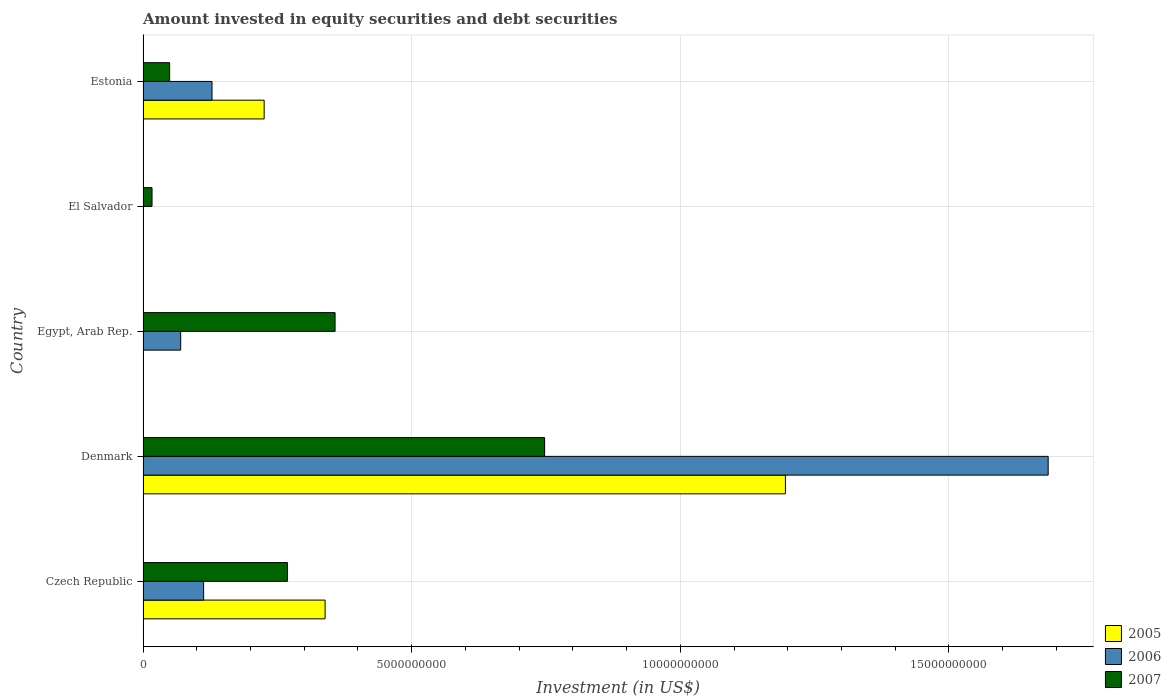How many different coloured bars are there?
Offer a terse response. 3. Are the number of bars on each tick of the Y-axis equal?
Ensure brevity in your answer.  No. What is the label of the 2nd group of bars from the top?
Your answer should be compact. El Salvador. What is the amount invested in equity securities and debt securities in 2007 in El Salvador?
Offer a very short reply. 1.67e+08. Across all countries, what is the maximum amount invested in equity securities and debt securities in 2007?
Provide a succinct answer. 7.47e+09. Across all countries, what is the minimum amount invested in equity securities and debt securities in 2005?
Your answer should be very brief. 0. In which country was the amount invested in equity securities and debt securities in 2007 maximum?
Provide a short and direct response. Denmark. What is the total amount invested in equity securities and debt securities in 2007 in the graph?
Your answer should be very brief. 1.44e+1. What is the difference between the amount invested in equity securities and debt securities in 2007 in Denmark and that in Egypt, Arab Rep.?
Offer a very short reply. 3.90e+09. What is the difference between the amount invested in equity securities and debt securities in 2006 in Czech Republic and the amount invested in equity securities and debt securities in 2005 in Egypt, Arab Rep.?
Make the answer very short. 1.13e+09. What is the average amount invested in equity securities and debt securities in 2006 per country?
Your answer should be compact. 3.99e+09. What is the difference between the amount invested in equity securities and debt securities in 2005 and amount invested in equity securities and debt securities in 2007 in Denmark?
Ensure brevity in your answer.  4.48e+09. In how many countries, is the amount invested in equity securities and debt securities in 2007 greater than 2000000000 US$?
Ensure brevity in your answer.  3. What is the ratio of the amount invested in equity securities and debt securities in 2007 in Czech Republic to that in Denmark?
Your answer should be very brief. 0.36. What is the difference between the highest and the second highest amount invested in equity securities and debt securities in 2006?
Make the answer very short. 1.56e+1. What is the difference between the highest and the lowest amount invested in equity securities and debt securities in 2006?
Provide a short and direct response. 1.68e+1. In how many countries, is the amount invested in equity securities and debt securities in 2006 greater than the average amount invested in equity securities and debt securities in 2006 taken over all countries?
Your answer should be very brief. 1. Is it the case that in every country, the sum of the amount invested in equity securities and debt securities in 2005 and amount invested in equity securities and debt securities in 2007 is greater than the amount invested in equity securities and debt securities in 2006?
Give a very brief answer. Yes. How many countries are there in the graph?
Keep it short and to the point. 5. What is the difference between two consecutive major ticks on the X-axis?
Keep it short and to the point. 5.00e+09. Are the values on the major ticks of X-axis written in scientific E-notation?
Keep it short and to the point. No. Does the graph contain any zero values?
Keep it short and to the point. Yes. Does the graph contain grids?
Keep it short and to the point. Yes. Where does the legend appear in the graph?
Your answer should be compact. Bottom right. What is the title of the graph?
Provide a short and direct response. Amount invested in equity securities and debt securities. Does "2012" appear as one of the legend labels in the graph?
Your answer should be very brief. No. What is the label or title of the X-axis?
Provide a succinct answer. Investment (in US$). What is the Investment (in US$) of 2005 in Czech Republic?
Make the answer very short. 3.39e+09. What is the Investment (in US$) in 2006 in Czech Republic?
Provide a short and direct response. 1.13e+09. What is the Investment (in US$) in 2007 in Czech Republic?
Provide a short and direct response. 2.69e+09. What is the Investment (in US$) of 2005 in Denmark?
Make the answer very short. 1.20e+1. What is the Investment (in US$) in 2006 in Denmark?
Your answer should be compact. 1.68e+1. What is the Investment (in US$) in 2007 in Denmark?
Keep it short and to the point. 7.47e+09. What is the Investment (in US$) of 2005 in Egypt, Arab Rep.?
Offer a terse response. 0. What is the Investment (in US$) in 2006 in Egypt, Arab Rep.?
Keep it short and to the point. 7.00e+08. What is the Investment (in US$) in 2007 in Egypt, Arab Rep.?
Offer a very short reply. 3.57e+09. What is the Investment (in US$) of 2005 in El Salvador?
Your answer should be very brief. 0. What is the Investment (in US$) in 2006 in El Salvador?
Ensure brevity in your answer.  0. What is the Investment (in US$) in 2007 in El Salvador?
Offer a very short reply. 1.67e+08. What is the Investment (in US$) of 2005 in Estonia?
Give a very brief answer. 2.25e+09. What is the Investment (in US$) in 2006 in Estonia?
Give a very brief answer. 1.28e+09. What is the Investment (in US$) in 2007 in Estonia?
Your answer should be compact. 4.95e+08. Across all countries, what is the maximum Investment (in US$) of 2005?
Keep it short and to the point. 1.20e+1. Across all countries, what is the maximum Investment (in US$) in 2006?
Offer a very short reply. 1.68e+1. Across all countries, what is the maximum Investment (in US$) in 2007?
Your response must be concise. 7.47e+09. Across all countries, what is the minimum Investment (in US$) of 2006?
Your answer should be compact. 0. Across all countries, what is the minimum Investment (in US$) of 2007?
Keep it short and to the point. 1.67e+08. What is the total Investment (in US$) in 2005 in the graph?
Your answer should be compact. 1.76e+1. What is the total Investment (in US$) in 2006 in the graph?
Offer a very short reply. 2.00e+1. What is the total Investment (in US$) in 2007 in the graph?
Give a very brief answer. 1.44e+1. What is the difference between the Investment (in US$) in 2005 in Czech Republic and that in Denmark?
Keep it short and to the point. -8.57e+09. What is the difference between the Investment (in US$) of 2006 in Czech Republic and that in Denmark?
Offer a very short reply. -1.57e+1. What is the difference between the Investment (in US$) in 2007 in Czech Republic and that in Denmark?
Ensure brevity in your answer.  -4.79e+09. What is the difference between the Investment (in US$) of 2006 in Czech Republic and that in Egypt, Arab Rep.?
Offer a very short reply. 4.27e+08. What is the difference between the Investment (in US$) in 2007 in Czech Republic and that in Egypt, Arab Rep.?
Make the answer very short. -8.87e+08. What is the difference between the Investment (in US$) in 2007 in Czech Republic and that in El Salvador?
Your response must be concise. 2.52e+09. What is the difference between the Investment (in US$) of 2005 in Czech Republic and that in Estonia?
Provide a succinct answer. 1.13e+09. What is the difference between the Investment (in US$) in 2006 in Czech Republic and that in Estonia?
Your answer should be very brief. -1.56e+08. What is the difference between the Investment (in US$) in 2007 in Czech Republic and that in Estonia?
Your answer should be very brief. 2.19e+09. What is the difference between the Investment (in US$) in 2006 in Denmark and that in Egypt, Arab Rep.?
Keep it short and to the point. 1.61e+1. What is the difference between the Investment (in US$) in 2007 in Denmark and that in Egypt, Arab Rep.?
Provide a short and direct response. 3.90e+09. What is the difference between the Investment (in US$) in 2007 in Denmark and that in El Salvador?
Provide a short and direct response. 7.31e+09. What is the difference between the Investment (in US$) in 2005 in Denmark and that in Estonia?
Ensure brevity in your answer.  9.70e+09. What is the difference between the Investment (in US$) in 2006 in Denmark and that in Estonia?
Provide a succinct answer. 1.56e+1. What is the difference between the Investment (in US$) in 2007 in Denmark and that in Estonia?
Offer a very short reply. 6.98e+09. What is the difference between the Investment (in US$) in 2007 in Egypt, Arab Rep. and that in El Salvador?
Provide a succinct answer. 3.41e+09. What is the difference between the Investment (in US$) in 2006 in Egypt, Arab Rep. and that in Estonia?
Provide a short and direct response. -5.83e+08. What is the difference between the Investment (in US$) in 2007 in Egypt, Arab Rep. and that in Estonia?
Ensure brevity in your answer.  3.08e+09. What is the difference between the Investment (in US$) of 2007 in El Salvador and that in Estonia?
Keep it short and to the point. -3.28e+08. What is the difference between the Investment (in US$) in 2005 in Czech Republic and the Investment (in US$) in 2006 in Denmark?
Provide a short and direct response. -1.35e+1. What is the difference between the Investment (in US$) of 2005 in Czech Republic and the Investment (in US$) of 2007 in Denmark?
Your answer should be compact. -4.09e+09. What is the difference between the Investment (in US$) of 2006 in Czech Republic and the Investment (in US$) of 2007 in Denmark?
Your response must be concise. -6.35e+09. What is the difference between the Investment (in US$) of 2005 in Czech Republic and the Investment (in US$) of 2006 in Egypt, Arab Rep.?
Your response must be concise. 2.69e+09. What is the difference between the Investment (in US$) in 2005 in Czech Republic and the Investment (in US$) in 2007 in Egypt, Arab Rep.?
Provide a succinct answer. -1.86e+08. What is the difference between the Investment (in US$) in 2006 in Czech Republic and the Investment (in US$) in 2007 in Egypt, Arab Rep.?
Your answer should be compact. -2.45e+09. What is the difference between the Investment (in US$) of 2005 in Czech Republic and the Investment (in US$) of 2007 in El Salvador?
Offer a terse response. 3.22e+09. What is the difference between the Investment (in US$) in 2006 in Czech Republic and the Investment (in US$) in 2007 in El Salvador?
Keep it short and to the point. 9.61e+08. What is the difference between the Investment (in US$) in 2005 in Czech Republic and the Investment (in US$) in 2006 in Estonia?
Provide a succinct answer. 2.10e+09. What is the difference between the Investment (in US$) in 2005 in Czech Republic and the Investment (in US$) in 2007 in Estonia?
Offer a terse response. 2.89e+09. What is the difference between the Investment (in US$) in 2006 in Czech Republic and the Investment (in US$) in 2007 in Estonia?
Provide a succinct answer. 6.33e+08. What is the difference between the Investment (in US$) of 2005 in Denmark and the Investment (in US$) of 2006 in Egypt, Arab Rep.?
Provide a succinct answer. 1.13e+1. What is the difference between the Investment (in US$) of 2005 in Denmark and the Investment (in US$) of 2007 in Egypt, Arab Rep.?
Your answer should be very brief. 8.38e+09. What is the difference between the Investment (in US$) of 2006 in Denmark and the Investment (in US$) of 2007 in Egypt, Arab Rep.?
Your answer should be compact. 1.33e+1. What is the difference between the Investment (in US$) in 2005 in Denmark and the Investment (in US$) in 2007 in El Salvador?
Give a very brief answer. 1.18e+1. What is the difference between the Investment (in US$) in 2006 in Denmark and the Investment (in US$) in 2007 in El Salvador?
Ensure brevity in your answer.  1.67e+1. What is the difference between the Investment (in US$) in 2005 in Denmark and the Investment (in US$) in 2006 in Estonia?
Keep it short and to the point. 1.07e+1. What is the difference between the Investment (in US$) in 2005 in Denmark and the Investment (in US$) in 2007 in Estonia?
Provide a succinct answer. 1.15e+1. What is the difference between the Investment (in US$) of 2006 in Denmark and the Investment (in US$) of 2007 in Estonia?
Offer a terse response. 1.64e+1. What is the difference between the Investment (in US$) of 2006 in Egypt, Arab Rep. and the Investment (in US$) of 2007 in El Salvador?
Keep it short and to the point. 5.34e+08. What is the difference between the Investment (in US$) of 2006 in Egypt, Arab Rep. and the Investment (in US$) of 2007 in Estonia?
Your answer should be compact. 2.06e+08. What is the average Investment (in US$) in 2005 per country?
Provide a succinct answer. 3.52e+09. What is the average Investment (in US$) of 2006 per country?
Make the answer very short. 3.99e+09. What is the average Investment (in US$) in 2007 per country?
Provide a succinct answer. 2.88e+09. What is the difference between the Investment (in US$) in 2005 and Investment (in US$) in 2006 in Czech Republic?
Your response must be concise. 2.26e+09. What is the difference between the Investment (in US$) of 2005 and Investment (in US$) of 2007 in Czech Republic?
Offer a terse response. 7.01e+08. What is the difference between the Investment (in US$) in 2006 and Investment (in US$) in 2007 in Czech Republic?
Your answer should be compact. -1.56e+09. What is the difference between the Investment (in US$) in 2005 and Investment (in US$) in 2006 in Denmark?
Ensure brevity in your answer.  -4.89e+09. What is the difference between the Investment (in US$) in 2005 and Investment (in US$) in 2007 in Denmark?
Provide a succinct answer. 4.48e+09. What is the difference between the Investment (in US$) in 2006 and Investment (in US$) in 2007 in Denmark?
Your response must be concise. 9.37e+09. What is the difference between the Investment (in US$) in 2006 and Investment (in US$) in 2007 in Egypt, Arab Rep.?
Keep it short and to the point. -2.87e+09. What is the difference between the Investment (in US$) in 2005 and Investment (in US$) in 2006 in Estonia?
Keep it short and to the point. 9.71e+08. What is the difference between the Investment (in US$) in 2005 and Investment (in US$) in 2007 in Estonia?
Your response must be concise. 1.76e+09. What is the difference between the Investment (in US$) in 2006 and Investment (in US$) in 2007 in Estonia?
Offer a terse response. 7.89e+08. What is the ratio of the Investment (in US$) in 2005 in Czech Republic to that in Denmark?
Your response must be concise. 0.28. What is the ratio of the Investment (in US$) in 2006 in Czech Republic to that in Denmark?
Offer a terse response. 0.07. What is the ratio of the Investment (in US$) in 2007 in Czech Republic to that in Denmark?
Offer a very short reply. 0.36. What is the ratio of the Investment (in US$) of 2006 in Czech Republic to that in Egypt, Arab Rep.?
Provide a succinct answer. 1.61. What is the ratio of the Investment (in US$) of 2007 in Czech Republic to that in Egypt, Arab Rep.?
Your answer should be compact. 0.75. What is the ratio of the Investment (in US$) of 2007 in Czech Republic to that in El Salvador?
Provide a succinct answer. 16.11. What is the ratio of the Investment (in US$) of 2005 in Czech Republic to that in Estonia?
Give a very brief answer. 1.5. What is the ratio of the Investment (in US$) in 2006 in Czech Republic to that in Estonia?
Offer a very short reply. 0.88. What is the ratio of the Investment (in US$) of 2007 in Czech Republic to that in Estonia?
Ensure brevity in your answer.  5.43. What is the ratio of the Investment (in US$) of 2006 in Denmark to that in Egypt, Arab Rep.?
Provide a short and direct response. 24.05. What is the ratio of the Investment (in US$) in 2007 in Denmark to that in Egypt, Arab Rep.?
Provide a short and direct response. 2.09. What is the ratio of the Investment (in US$) of 2007 in Denmark to that in El Salvador?
Provide a succinct answer. 44.81. What is the ratio of the Investment (in US$) of 2005 in Denmark to that in Estonia?
Offer a very short reply. 5.3. What is the ratio of the Investment (in US$) in 2006 in Denmark to that in Estonia?
Offer a very short reply. 13.13. What is the ratio of the Investment (in US$) of 2007 in Denmark to that in Estonia?
Ensure brevity in your answer.  15.11. What is the ratio of the Investment (in US$) in 2007 in Egypt, Arab Rep. to that in El Salvador?
Provide a succinct answer. 21.43. What is the ratio of the Investment (in US$) of 2006 in Egypt, Arab Rep. to that in Estonia?
Your answer should be very brief. 0.55. What is the ratio of the Investment (in US$) of 2007 in Egypt, Arab Rep. to that in Estonia?
Keep it short and to the point. 7.22. What is the ratio of the Investment (in US$) in 2007 in El Salvador to that in Estonia?
Make the answer very short. 0.34. What is the difference between the highest and the second highest Investment (in US$) in 2005?
Your answer should be compact. 8.57e+09. What is the difference between the highest and the second highest Investment (in US$) in 2006?
Offer a terse response. 1.56e+1. What is the difference between the highest and the second highest Investment (in US$) in 2007?
Offer a terse response. 3.90e+09. What is the difference between the highest and the lowest Investment (in US$) of 2005?
Provide a short and direct response. 1.20e+1. What is the difference between the highest and the lowest Investment (in US$) in 2006?
Your response must be concise. 1.68e+1. What is the difference between the highest and the lowest Investment (in US$) in 2007?
Give a very brief answer. 7.31e+09. 